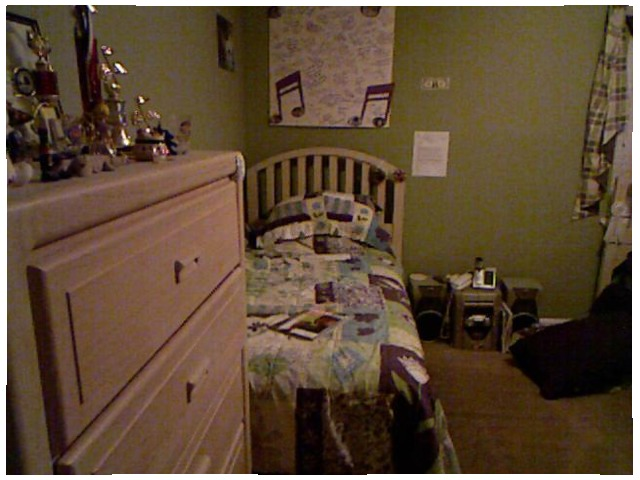<image>
Is the book on the bed? Yes. Looking at the image, I can see the book is positioned on top of the bed, with the bed providing support. Is the money on the wall? Yes. Looking at the image, I can see the money is positioned on top of the wall, with the wall providing support. Where is the book in relation to the dresser? Is it on the dresser? No. The book is not positioned on the dresser. They may be near each other, but the book is not supported by or resting on top of the dresser. Is the poster on the wall? No. The poster is not positioned on the wall. They may be near each other, but the poster is not supported by or resting on top of the wall. Where is the bed in relation to the stereo? Is it on the stereo? No. The bed is not positioned on the stereo. They may be near each other, but the bed is not supported by or resting on top of the stereo. 